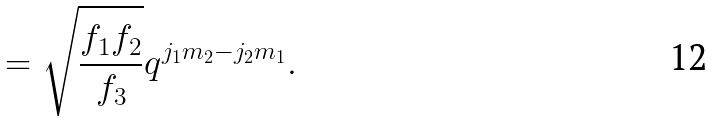<formula> <loc_0><loc_0><loc_500><loc_500>= \sqrt { \frac { f _ { 1 } f _ { 2 } } { f _ { 3 } } } q ^ { j _ { 1 } m _ { 2 } - j _ { 2 } m _ { 1 } } .</formula> 